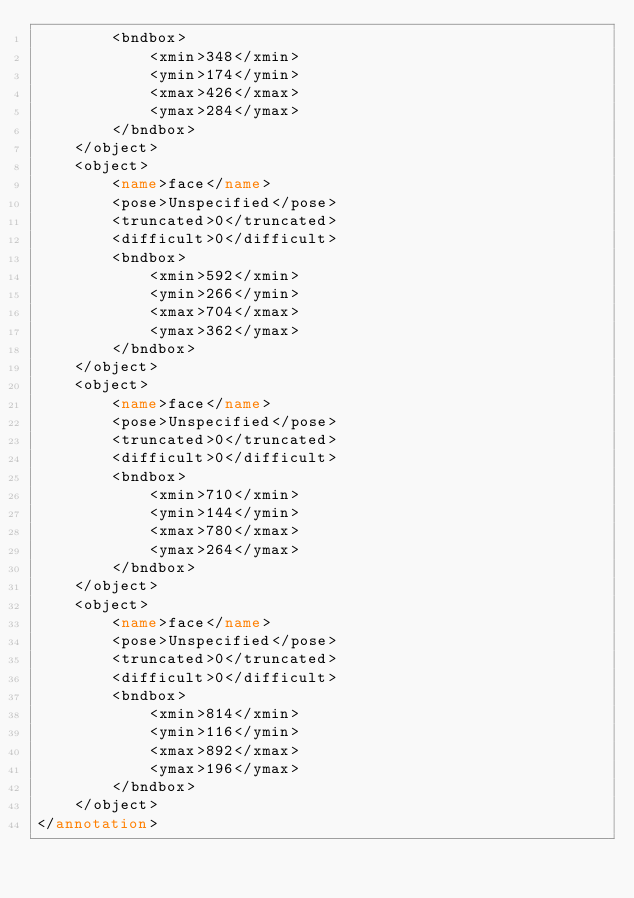Convert code to text. <code><loc_0><loc_0><loc_500><loc_500><_XML_>        <bndbox>
            <xmin>348</xmin>
            <ymin>174</ymin>
            <xmax>426</xmax>
            <ymax>284</ymax>
        </bndbox>
    </object>
    <object>
        <name>face</name>
        <pose>Unspecified</pose>
        <truncated>0</truncated>
        <difficult>0</difficult>
        <bndbox>
            <xmin>592</xmin>
            <ymin>266</ymin>
            <xmax>704</xmax>
            <ymax>362</ymax>
        </bndbox>
    </object>
    <object>
        <name>face</name>
        <pose>Unspecified</pose>
        <truncated>0</truncated>
        <difficult>0</difficult>
        <bndbox>
            <xmin>710</xmin>
            <ymin>144</ymin>
            <xmax>780</xmax>
            <ymax>264</ymax>
        </bndbox>
    </object>
    <object>
        <name>face</name>
        <pose>Unspecified</pose>
        <truncated>0</truncated>
        <difficult>0</difficult>
        <bndbox>
            <xmin>814</xmin>
            <ymin>116</ymin>
            <xmax>892</xmax>
            <ymax>196</ymax>
        </bndbox>
    </object>
</annotation>
</code> 